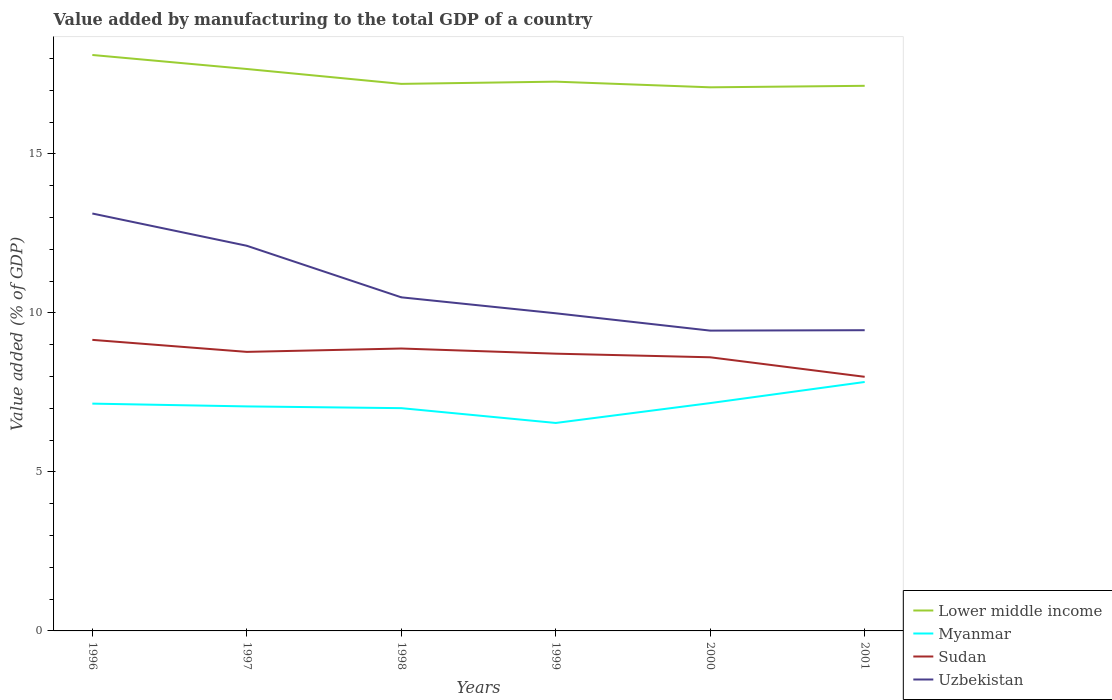How many different coloured lines are there?
Provide a short and direct response. 4. Does the line corresponding to Lower middle income intersect with the line corresponding to Myanmar?
Your answer should be compact. No. Is the number of lines equal to the number of legend labels?
Ensure brevity in your answer.  Yes. Across all years, what is the maximum value added by manufacturing to the total GDP in Lower middle income?
Offer a very short reply. 17.1. What is the total value added by manufacturing to the total GDP in Lower middle income in the graph?
Your response must be concise. 0.47. What is the difference between the highest and the second highest value added by manufacturing to the total GDP in Lower middle income?
Offer a terse response. 1.02. How many years are there in the graph?
Make the answer very short. 6. Does the graph contain grids?
Offer a very short reply. No. Where does the legend appear in the graph?
Make the answer very short. Bottom right. How are the legend labels stacked?
Give a very brief answer. Vertical. What is the title of the graph?
Offer a terse response. Value added by manufacturing to the total GDP of a country. What is the label or title of the Y-axis?
Make the answer very short. Value added (% of GDP). What is the Value added (% of GDP) in Lower middle income in 1996?
Your response must be concise. 18.11. What is the Value added (% of GDP) in Myanmar in 1996?
Ensure brevity in your answer.  7.15. What is the Value added (% of GDP) of Sudan in 1996?
Offer a terse response. 9.15. What is the Value added (% of GDP) of Uzbekistan in 1996?
Offer a very short reply. 13.13. What is the Value added (% of GDP) of Lower middle income in 1997?
Make the answer very short. 17.67. What is the Value added (% of GDP) in Myanmar in 1997?
Your answer should be compact. 7.06. What is the Value added (% of GDP) in Sudan in 1997?
Your answer should be very brief. 8.78. What is the Value added (% of GDP) in Uzbekistan in 1997?
Your response must be concise. 12.11. What is the Value added (% of GDP) of Lower middle income in 1998?
Keep it short and to the point. 17.2. What is the Value added (% of GDP) of Myanmar in 1998?
Your answer should be very brief. 7.01. What is the Value added (% of GDP) of Sudan in 1998?
Provide a short and direct response. 8.88. What is the Value added (% of GDP) in Uzbekistan in 1998?
Keep it short and to the point. 10.49. What is the Value added (% of GDP) in Lower middle income in 1999?
Your answer should be compact. 17.27. What is the Value added (% of GDP) of Myanmar in 1999?
Keep it short and to the point. 6.54. What is the Value added (% of GDP) of Sudan in 1999?
Keep it short and to the point. 8.72. What is the Value added (% of GDP) in Uzbekistan in 1999?
Ensure brevity in your answer.  9.99. What is the Value added (% of GDP) in Lower middle income in 2000?
Make the answer very short. 17.1. What is the Value added (% of GDP) in Myanmar in 2000?
Ensure brevity in your answer.  7.16. What is the Value added (% of GDP) of Sudan in 2000?
Provide a succinct answer. 8.61. What is the Value added (% of GDP) of Uzbekistan in 2000?
Offer a terse response. 9.44. What is the Value added (% of GDP) of Lower middle income in 2001?
Your response must be concise. 17.14. What is the Value added (% of GDP) of Myanmar in 2001?
Offer a terse response. 7.83. What is the Value added (% of GDP) of Sudan in 2001?
Keep it short and to the point. 7.99. What is the Value added (% of GDP) in Uzbekistan in 2001?
Offer a very short reply. 9.46. Across all years, what is the maximum Value added (% of GDP) in Lower middle income?
Keep it short and to the point. 18.11. Across all years, what is the maximum Value added (% of GDP) of Myanmar?
Make the answer very short. 7.83. Across all years, what is the maximum Value added (% of GDP) of Sudan?
Offer a terse response. 9.15. Across all years, what is the maximum Value added (% of GDP) of Uzbekistan?
Offer a terse response. 13.13. Across all years, what is the minimum Value added (% of GDP) of Lower middle income?
Make the answer very short. 17.1. Across all years, what is the minimum Value added (% of GDP) in Myanmar?
Give a very brief answer. 6.54. Across all years, what is the minimum Value added (% of GDP) in Sudan?
Your response must be concise. 7.99. Across all years, what is the minimum Value added (% of GDP) in Uzbekistan?
Your answer should be very brief. 9.44. What is the total Value added (% of GDP) in Lower middle income in the graph?
Your answer should be compact. 104.5. What is the total Value added (% of GDP) in Myanmar in the graph?
Your answer should be compact. 42.75. What is the total Value added (% of GDP) of Sudan in the graph?
Provide a short and direct response. 52.12. What is the total Value added (% of GDP) of Uzbekistan in the graph?
Offer a terse response. 64.62. What is the difference between the Value added (% of GDP) of Lower middle income in 1996 and that in 1997?
Your answer should be very brief. 0.44. What is the difference between the Value added (% of GDP) in Myanmar in 1996 and that in 1997?
Give a very brief answer. 0.09. What is the difference between the Value added (% of GDP) in Sudan in 1996 and that in 1997?
Keep it short and to the point. 0.38. What is the difference between the Value added (% of GDP) in Uzbekistan in 1996 and that in 1997?
Provide a short and direct response. 1.01. What is the difference between the Value added (% of GDP) of Lower middle income in 1996 and that in 1998?
Offer a terse response. 0.91. What is the difference between the Value added (% of GDP) in Myanmar in 1996 and that in 1998?
Give a very brief answer. 0.14. What is the difference between the Value added (% of GDP) of Sudan in 1996 and that in 1998?
Give a very brief answer. 0.27. What is the difference between the Value added (% of GDP) of Uzbekistan in 1996 and that in 1998?
Your answer should be very brief. 2.64. What is the difference between the Value added (% of GDP) in Lower middle income in 1996 and that in 1999?
Offer a very short reply. 0.84. What is the difference between the Value added (% of GDP) of Myanmar in 1996 and that in 1999?
Keep it short and to the point. 0.61. What is the difference between the Value added (% of GDP) in Sudan in 1996 and that in 1999?
Keep it short and to the point. 0.43. What is the difference between the Value added (% of GDP) in Uzbekistan in 1996 and that in 1999?
Make the answer very short. 3.14. What is the difference between the Value added (% of GDP) in Lower middle income in 1996 and that in 2000?
Give a very brief answer. 1.02. What is the difference between the Value added (% of GDP) of Myanmar in 1996 and that in 2000?
Give a very brief answer. -0.02. What is the difference between the Value added (% of GDP) in Sudan in 1996 and that in 2000?
Your answer should be very brief. 0.55. What is the difference between the Value added (% of GDP) in Uzbekistan in 1996 and that in 2000?
Provide a succinct answer. 3.68. What is the difference between the Value added (% of GDP) of Lower middle income in 1996 and that in 2001?
Your answer should be very brief. 0.97. What is the difference between the Value added (% of GDP) of Myanmar in 1996 and that in 2001?
Your answer should be compact. -0.68. What is the difference between the Value added (% of GDP) in Sudan in 1996 and that in 2001?
Offer a terse response. 1.16. What is the difference between the Value added (% of GDP) in Uzbekistan in 1996 and that in 2001?
Offer a terse response. 3.67. What is the difference between the Value added (% of GDP) in Lower middle income in 1997 and that in 1998?
Your response must be concise. 0.47. What is the difference between the Value added (% of GDP) in Myanmar in 1997 and that in 1998?
Offer a terse response. 0.05. What is the difference between the Value added (% of GDP) in Sudan in 1997 and that in 1998?
Ensure brevity in your answer.  -0.11. What is the difference between the Value added (% of GDP) of Uzbekistan in 1997 and that in 1998?
Make the answer very short. 1.62. What is the difference between the Value added (% of GDP) of Lower middle income in 1997 and that in 1999?
Offer a terse response. 0.4. What is the difference between the Value added (% of GDP) of Myanmar in 1997 and that in 1999?
Offer a terse response. 0.52. What is the difference between the Value added (% of GDP) of Sudan in 1997 and that in 1999?
Your answer should be very brief. 0.06. What is the difference between the Value added (% of GDP) of Uzbekistan in 1997 and that in 1999?
Give a very brief answer. 2.12. What is the difference between the Value added (% of GDP) in Lower middle income in 1997 and that in 2000?
Offer a terse response. 0.58. What is the difference between the Value added (% of GDP) in Myanmar in 1997 and that in 2000?
Your answer should be compact. -0.1. What is the difference between the Value added (% of GDP) in Sudan in 1997 and that in 2000?
Keep it short and to the point. 0.17. What is the difference between the Value added (% of GDP) in Uzbekistan in 1997 and that in 2000?
Give a very brief answer. 2.67. What is the difference between the Value added (% of GDP) in Lower middle income in 1997 and that in 2001?
Ensure brevity in your answer.  0.53. What is the difference between the Value added (% of GDP) of Myanmar in 1997 and that in 2001?
Your answer should be very brief. -0.77. What is the difference between the Value added (% of GDP) of Sudan in 1997 and that in 2001?
Your answer should be very brief. 0.78. What is the difference between the Value added (% of GDP) of Uzbekistan in 1997 and that in 2001?
Your response must be concise. 2.66. What is the difference between the Value added (% of GDP) in Lower middle income in 1998 and that in 1999?
Give a very brief answer. -0.07. What is the difference between the Value added (% of GDP) in Myanmar in 1998 and that in 1999?
Offer a very short reply. 0.47. What is the difference between the Value added (% of GDP) in Sudan in 1998 and that in 1999?
Provide a succinct answer. 0.16. What is the difference between the Value added (% of GDP) in Uzbekistan in 1998 and that in 1999?
Give a very brief answer. 0.5. What is the difference between the Value added (% of GDP) in Lower middle income in 1998 and that in 2000?
Offer a terse response. 0.11. What is the difference between the Value added (% of GDP) of Myanmar in 1998 and that in 2000?
Provide a succinct answer. -0.16. What is the difference between the Value added (% of GDP) of Sudan in 1998 and that in 2000?
Your response must be concise. 0.28. What is the difference between the Value added (% of GDP) of Uzbekistan in 1998 and that in 2000?
Your answer should be very brief. 1.05. What is the difference between the Value added (% of GDP) in Lower middle income in 1998 and that in 2001?
Keep it short and to the point. 0.06. What is the difference between the Value added (% of GDP) in Myanmar in 1998 and that in 2001?
Give a very brief answer. -0.82. What is the difference between the Value added (% of GDP) of Sudan in 1998 and that in 2001?
Provide a succinct answer. 0.89. What is the difference between the Value added (% of GDP) of Uzbekistan in 1998 and that in 2001?
Ensure brevity in your answer.  1.03. What is the difference between the Value added (% of GDP) of Lower middle income in 1999 and that in 2000?
Your response must be concise. 0.18. What is the difference between the Value added (% of GDP) of Myanmar in 1999 and that in 2000?
Your answer should be very brief. -0.62. What is the difference between the Value added (% of GDP) of Sudan in 1999 and that in 2000?
Offer a terse response. 0.11. What is the difference between the Value added (% of GDP) in Uzbekistan in 1999 and that in 2000?
Your answer should be very brief. 0.55. What is the difference between the Value added (% of GDP) of Lower middle income in 1999 and that in 2001?
Provide a short and direct response. 0.13. What is the difference between the Value added (% of GDP) of Myanmar in 1999 and that in 2001?
Your answer should be compact. -1.29. What is the difference between the Value added (% of GDP) of Sudan in 1999 and that in 2001?
Your response must be concise. 0.73. What is the difference between the Value added (% of GDP) in Uzbekistan in 1999 and that in 2001?
Your response must be concise. 0.53. What is the difference between the Value added (% of GDP) in Lower middle income in 2000 and that in 2001?
Give a very brief answer. -0.05. What is the difference between the Value added (% of GDP) in Myanmar in 2000 and that in 2001?
Make the answer very short. -0.66. What is the difference between the Value added (% of GDP) in Sudan in 2000 and that in 2001?
Offer a terse response. 0.61. What is the difference between the Value added (% of GDP) of Uzbekistan in 2000 and that in 2001?
Give a very brief answer. -0.01. What is the difference between the Value added (% of GDP) of Lower middle income in 1996 and the Value added (% of GDP) of Myanmar in 1997?
Make the answer very short. 11.05. What is the difference between the Value added (% of GDP) of Lower middle income in 1996 and the Value added (% of GDP) of Sudan in 1997?
Keep it short and to the point. 9.34. What is the difference between the Value added (% of GDP) in Lower middle income in 1996 and the Value added (% of GDP) in Uzbekistan in 1997?
Provide a succinct answer. 6. What is the difference between the Value added (% of GDP) of Myanmar in 1996 and the Value added (% of GDP) of Sudan in 1997?
Your answer should be very brief. -1.63. What is the difference between the Value added (% of GDP) in Myanmar in 1996 and the Value added (% of GDP) in Uzbekistan in 1997?
Your response must be concise. -4.96. What is the difference between the Value added (% of GDP) in Sudan in 1996 and the Value added (% of GDP) in Uzbekistan in 1997?
Keep it short and to the point. -2.96. What is the difference between the Value added (% of GDP) in Lower middle income in 1996 and the Value added (% of GDP) in Myanmar in 1998?
Offer a terse response. 11.11. What is the difference between the Value added (% of GDP) in Lower middle income in 1996 and the Value added (% of GDP) in Sudan in 1998?
Provide a short and direct response. 9.23. What is the difference between the Value added (% of GDP) in Lower middle income in 1996 and the Value added (% of GDP) in Uzbekistan in 1998?
Your answer should be compact. 7.62. What is the difference between the Value added (% of GDP) in Myanmar in 1996 and the Value added (% of GDP) in Sudan in 1998?
Your answer should be compact. -1.73. What is the difference between the Value added (% of GDP) of Myanmar in 1996 and the Value added (% of GDP) of Uzbekistan in 1998?
Keep it short and to the point. -3.34. What is the difference between the Value added (% of GDP) of Sudan in 1996 and the Value added (% of GDP) of Uzbekistan in 1998?
Ensure brevity in your answer.  -1.34. What is the difference between the Value added (% of GDP) in Lower middle income in 1996 and the Value added (% of GDP) in Myanmar in 1999?
Offer a terse response. 11.57. What is the difference between the Value added (% of GDP) of Lower middle income in 1996 and the Value added (% of GDP) of Sudan in 1999?
Provide a short and direct response. 9.39. What is the difference between the Value added (% of GDP) in Lower middle income in 1996 and the Value added (% of GDP) in Uzbekistan in 1999?
Give a very brief answer. 8.12. What is the difference between the Value added (% of GDP) of Myanmar in 1996 and the Value added (% of GDP) of Sudan in 1999?
Keep it short and to the point. -1.57. What is the difference between the Value added (% of GDP) in Myanmar in 1996 and the Value added (% of GDP) in Uzbekistan in 1999?
Give a very brief answer. -2.84. What is the difference between the Value added (% of GDP) of Sudan in 1996 and the Value added (% of GDP) of Uzbekistan in 1999?
Provide a short and direct response. -0.84. What is the difference between the Value added (% of GDP) of Lower middle income in 1996 and the Value added (% of GDP) of Myanmar in 2000?
Ensure brevity in your answer.  10.95. What is the difference between the Value added (% of GDP) in Lower middle income in 1996 and the Value added (% of GDP) in Sudan in 2000?
Offer a terse response. 9.51. What is the difference between the Value added (% of GDP) of Lower middle income in 1996 and the Value added (% of GDP) of Uzbekistan in 2000?
Offer a terse response. 8.67. What is the difference between the Value added (% of GDP) of Myanmar in 1996 and the Value added (% of GDP) of Sudan in 2000?
Keep it short and to the point. -1.46. What is the difference between the Value added (% of GDP) in Myanmar in 1996 and the Value added (% of GDP) in Uzbekistan in 2000?
Keep it short and to the point. -2.3. What is the difference between the Value added (% of GDP) in Sudan in 1996 and the Value added (% of GDP) in Uzbekistan in 2000?
Make the answer very short. -0.29. What is the difference between the Value added (% of GDP) in Lower middle income in 1996 and the Value added (% of GDP) in Myanmar in 2001?
Your response must be concise. 10.28. What is the difference between the Value added (% of GDP) of Lower middle income in 1996 and the Value added (% of GDP) of Sudan in 2001?
Keep it short and to the point. 10.12. What is the difference between the Value added (% of GDP) in Lower middle income in 1996 and the Value added (% of GDP) in Uzbekistan in 2001?
Offer a terse response. 8.66. What is the difference between the Value added (% of GDP) in Myanmar in 1996 and the Value added (% of GDP) in Sudan in 2001?
Your answer should be compact. -0.84. What is the difference between the Value added (% of GDP) of Myanmar in 1996 and the Value added (% of GDP) of Uzbekistan in 2001?
Your response must be concise. -2.31. What is the difference between the Value added (% of GDP) of Sudan in 1996 and the Value added (% of GDP) of Uzbekistan in 2001?
Your answer should be very brief. -0.3. What is the difference between the Value added (% of GDP) of Lower middle income in 1997 and the Value added (% of GDP) of Myanmar in 1998?
Keep it short and to the point. 10.67. What is the difference between the Value added (% of GDP) of Lower middle income in 1997 and the Value added (% of GDP) of Sudan in 1998?
Make the answer very short. 8.79. What is the difference between the Value added (% of GDP) in Lower middle income in 1997 and the Value added (% of GDP) in Uzbekistan in 1998?
Ensure brevity in your answer.  7.18. What is the difference between the Value added (% of GDP) in Myanmar in 1997 and the Value added (% of GDP) in Sudan in 1998?
Offer a very short reply. -1.82. What is the difference between the Value added (% of GDP) in Myanmar in 1997 and the Value added (% of GDP) in Uzbekistan in 1998?
Offer a very short reply. -3.43. What is the difference between the Value added (% of GDP) of Sudan in 1997 and the Value added (% of GDP) of Uzbekistan in 1998?
Give a very brief answer. -1.72. What is the difference between the Value added (% of GDP) in Lower middle income in 1997 and the Value added (% of GDP) in Myanmar in 1999?
Ensure brevity in your answer.  11.13. What is the difference between the Value added (% of GDP) in Lower middle income in 1997 and the Value added (% of GDP) in Sudan in 1999?
Ensure brevity in your answer.  8.95. What is the difference between the Value added (% of GDP) in Lower middle income in 1997 and the Value added (% of GDP) in Uzbekistan in 1999?
Keep it short and to the point. 7.68. What is the difference between the Value added (% of GDP) of Myanmar in 1997 and the Value added (% of GDP) of Sudan in 1999?
Provide a short and direct response. -1.66. What is the difference between the Value added (% of GDP) in Myanmar in 1997 and the Value added (% of GDP) in Uzbekistan in 1999?
Make the answer very short. -2.93. What is the difference between the Value added (% of GDP) of Sudan in 1997 and the Value added (% of GDP) of Uzbekistan in 1999?
Provide a short and direct response. -1.21. What is the difference between the Value added (% of GDP) in Lower middle income in 1997 and the Value added (% of GDP) in Myanmar in 2000?
Provide a succinct answer. 10.51. What is the difference between the Value added (% of GDP) of Lower middle income in 1997 and the Value added (% of GDP) of Sudan in 2000?
Provide a succinct answer. 9.07. What is the difference between the Value added (% of GDP) of Lower middle income in 1997 and the Value added (% of GDP) of Uzbekistan in 2000?
Ensure brevity in your answer.  8.23. What is the difference between the Value added (% of GDP) of Myanmar in 1997 and the Value added (% of GDP) of Sudan in 2000?
Your answer should be very brief. -1.54. What is the difference between the Value added (% of GDP) of Myanmar in 1997 and the Value added (% of GDP) of Uzbekistan in 2000?
Provide a short and direct response. -2.38. What is the difference between the Value added (% of GDP) of Sudan in 1997 and the Value added (% of GDP) of Uzbekistan in 2000?
Give a very brief answer. -0.67. What is the difference between the Value added (% of GDP) in Lower middle income in 1997 and the Value added (% of GDP) in Myanmar in 2001?
Offer a terse response. 9.84. What is the difference between the Value added (% of GDP) in Lower middle income in 1997 and the Value added (% of GDP) in Sudan in 2001?
Offer a very short reply. 9.68. What is the difference between the Value added (% of GDP) of Lower middle income in 1997 and the Value added (% of GDP) of Uzbekistan in 2001?
Make the answer very short. 8.21. What is the difference between the Value added (% of GDP) of Myanmar in 1997 and the Value added (% of GDP) of Sudan in 2001?
Your answer should be very brief. -0.93. What is the difference between the Value added (% of GDP) of Myanmar in 1997 and the Value added (% of GDP) of Uzbekistan in 2001?
Your answer should be very brief. -2.4. What is the difference between the Value added (% of GDP) of Sudan in 1997 and the Value added (% of GDP) of Uzbekistan in 2001?
Your answer should be compact. -0.68. What is the difference between the Value added (% of GDP) in Lower middle income in 1998 and the Value added (% of GDP) in Myanmar in 1999?
Offer a very short reply. 10.66. What is the difference between the Value added (% of GDP) of Lower middle income in 1998 and the Value added (% of GDP) of Sudan in 1999?
Your response must be concise. 8.48. What is the difference between the Value added (% of GDP) in Lower middle income in 1998 and the Value added (% of GDP) in Uzbekistan in 1999?
Your answer should be very brief. 7.21. What is the difference between the Value added (% of GDP) of Myanmar in 1998 and the Value added (% of GDP) of Sudan in 1999?
Keep it short and to the point. -1.71. What is the difference between the Value added (% of GDP) in Myanmar in 1998 and the Value added (% of GDP) in Uzbekistan in 1999?
Make the answer very short. -2.98. What is the difference between the Value added (% of GDP) in Sudan in 1998 and the Value added (% of GDP) in Uzbekistan in 1999?
Your response must be concise. -1.11. What is the difference between the Value added (% of GDP) in Lower middle income in 1998 and the Value added (% of GDP) in Myanmar in 2000?
Provide a succinct answer. 10.04. What is the difference between the Value added (% of GDP) in Lower middle income in 1998 and the Value added (% of GDP) in Sudan in 2000?
Give a very brief answer. 8.6. What is the difference between the Value added (% of GDP) in Lower middle income in 1998 and the Value added (% of GDP) in Uzbekistan in 2000?
Offer a very short reply. 7.76. What is the difference between the Value added (% of GDP) in Myanmar in 1998 and the Value added (% of GDP) in Sudan in 2000?
Your response must be concise. -1.6. What is the difference between the Value added (% of GDP) of Myanmar in 1998 and the Value added (% of GDP) of Uzbekistan in 2000?
Make the answer very short. -2.44. What is the difference between the Value added (% of GDP) in Sudan in 1998 and the Value added (% of GDP) in Uzbekistan in 2000?
Provide a short and direct response. -0.56. What is the difference between the Value added (% of GDP) of Lower middle income in 1998 and the Value added (% of GDP) of Myanmar in 2001?
Your answer should be very brief. 9.37. What is the difference between the Value added (% of GDP) in Lower middle income in 1998 and the Value added (% of GDP) in Sudan in 2001?
Make the answer very short. 9.21. What is the difference between the Value added (% of GDP) in Lower middle income in 1998 and the Value added (% of GDP) in Uzbekistan in 2001?
Provide a succinct answer. 7.75. What is the difference between the Value added (% of GDP) of Myanmar in 1998 and the Value added (% of GDP) of Sudan in 2001?
Make the answer very short. -0.99. What is the difference between the Value added (% of GDP) in Myanmar in 1998 and the Value added (% of GDP) in Uzbekistan in 2001?
Offer a very short reply. -2.45. What is the difference between the Value added (% of GDP) of Sudan in 1998 and the Value added (% of GDP) of Uzbekistan in 2001?
Make the answer very short. -0.58. What is the difference between the Value added (% of GDP) of Lower middle income in 1999 and the Value added (% of GDP) of Myanmar in 2000?
Give a very brief answer. 10.11. What is the difference between the Value added (% of GDP) in Lower middle income in 1999 and the Value added (% of GDP) in Sudan in 2000?
Your response must be concise. 8.67. What is the difference between the Value added (% of GDP) in Lower middle income in 1999 and the Value added (% of GDP) in Uzbekistan in 2000?
Offer a terse response. 7.83. What is the difference between the Value added (% of GDP) of Myanmar in 1999 and the Value added (% of GDP) of Sudan in 2000?
Your answer should be very brief. -2.07. What is the difference between the Value added (% of GDP) of Myanmar in 1999 and the Value added (% of GDP) of Uzbekistan in 2000?
Provide a short and direct response. -2.9. What is the difference between the Value added (% of GDP) in Sudan in 1999 and the Value added (% of GDP) in Uzbekistan in 2000?
Provide a succinct answer. -0.72. What is the difference between the Value added (% of GDP) of Lower middle income in 1999 and the Value added (% of GDP) of Myanmar in 2001?
Make the answer very short. 9.44. What is the difference between the Value added (% of GDP) of Lower middle income in 1999 and the Value added (% of GDP) of Sudan in 2001?
Offer a terse response. 9.28. What is the difference between the Value added (% of GDP) in Lower middle income in 1999 and the Value added (% of GDP) in Uzbekistan in 2001?
Provide a short and direct response. 7.82. What is the difference between the Value added (% of GDP) in Myanmar in 1999 and the Value added (% of GDP) in Sudan in 2001?
Offer a terse response. -1.45. What is the difference between the Value added (% of GDP) in Myanmar in 1999 and the Value added (% of GDP) in Uzbekistan in 2001?
Make the answer very short. -2.92. What is the difference between the Value added (% of GDP) in Sudan in 1999 and the Value added (% of GDP) in Uzbekistan in 2001?
Ensure brevity in your answer.  -0.74. What is the difference between the Value added (% of GDP) of Lower middle income in 2000 and the Value added (% of GDP) of Myanmar in 2001?
Your answer should be compact. 9.27. What is the difference between the Value added (% of GDP) of Lower middle income in 2000 and the Value added (% of GDP) of Sudan in 2001?
Give a very brief answer. 9.1. What is the difference between the Value added (% of GDP) of Lower middle income in 2000 and the Value added (% of GDP) of Uzbekistan in 2001?
Offer a very short reply. 7.64. What is the difference between the Value added (% of GDP) of Myanmar in 2000 and the Value added (% of GDP) of Sudan in 2001?
Offer a very short reply. -0.83. What is the difference between the Value added (% of GDP) of Myanmar in 2000 and the Value added (% of GDP) of Uzbekistan in 2001?
Offer a terse response. -2.29. What is the difference between the Value added (% of GDP) in Sudan in 2000 and the Value added (% of GDP) in Uzbekistan in 2001?
Your response must be concise. -0.85. What is the average Value added (% of GDP) of Lower middle income per year?
Offer a terse response. 17.42. What is the average Value added (% of GDP) in Myanmar per year?
Give a very brief answer. 7.12. What is the average Value added (% of GDP) of Sudan per year?
Your answer should be compact. 8.69. What is the average Value added (% of GDP) in Uzbekistan per year?
Ensure brevity in your answer.  10.77. In the year 1996, what is the difference between the Value added (% of GDP) of Lower middle income and Value added (% of GDP) of Myanmar?
Provide a short and direct response. 10.96. In the year 1996, what is the difference between the Value added (% of GDP) of Lower middle income and Value added (% of GDP) of Sudan?
Ensure brevity in your answer.  8.96. In the year 1996, what is the difference between the Value added (% of GDP) in Lower middle income and Value added (% of GDP) in Uzbekistan?
Your response must be concise. 4.99. In the year 1996, what is the difference between the Value added (% of GDP) in Myanmar and Value added (% of GDP) in Sudan?
Give a very brief answer. -2.01. In the year 1996, what is the difference between the Value added (% of GDP) of Myanmar and Value added (% of GDP) of Uzbekistan?
Provide a succinct answer. -5.98. In the year 1996, what is the difference between the Value added (% of GDP) in Sudan and Value added (% of GDP) in Uzbekistan?
Provide a succinct answer. -3.97. In the year 1997, what is the difference between the Value added (% of GDP) in Lower middle income and Value added (% of GDP) in Myanmar?
Provide a succinct answer. 10.61. In the year 1997, what is the difference between the Value added (% of GDP) in Lower middle income and Value added (% of GDP) in Sudan?
Your answer should be compact. 8.9. In the year 1997, what is the difference between the Value added (% of GDP) in Lower middle income and Value added (% of GDP) in Uzbekistan?
Your response must be concise. 5.56. In the year 1997, what is the difference between the Value added (% of GDP) of Myanmar and Value added (% of GDP) of Sudan?
Make the answer very short. -1.72. In the year 1997, what is the difference between the Value added (% of GDP) in Myanmar and Value added (% of GDP) in Uzbekistan?
Keep it short and to the point. -5.05. In the year 1997, what is the difference between the Value added (% of GDP) in Sudan and Value added (% of GDP) in Uzbekistan?
Offer a terse response. -3.34. In the year 1998, what is the difference between the Value added (% of GDP) in Lower middle income and Value added (% of GDP) in Myanmar?
Provide a succinct answer. 10.2. In the year 1998, what is the difference between the Value added (% of GDP) of Lower middle income and Value added (% of GDP) of Sudan?
Provide a short and direct response. 8.32. In the year 1998, what is the difference between the Value added (% of GDP) in Lower middle income and Value added (% of GDP) in Uzbekistan?
Provide a short and direct response. 6.71. In the year 1998, what is the difference between the Value added (% of GDP) of Myanmar and Value added (% of GDP) of Sudan?
Offer a very short reply. -1.88. In the year 1998, what is the difference between the Value added (% of GDP) of Myanmar and Value added (% of GDP) of Uzbekistan?
Offer a terse response. -3.49. In the year 1998, what is the difference between the Value added (% of GDP) in Sudan and Value added (% of GDP) in Uzbekistan?
Your answer should be very brief. -1.61. In the year 1999, what is the difference between the Value added (% of GDP) of Lower middle income and Value added (% of GDP) of Myanmar?
Your answer should be compact. 10.73. In the year 1999, what is the difference between the Value added (% of GDP) in Lower middle income and Value added (% of GDP) in Sudan?
Give a very brief answer. 8.55. In the year 1999, what is the difference between the Value added (% of GDP) in Lower middle income and Value added (% of GDP) in Uzbekistan?
Offer a very short reply. 7.28. In the year 1999, what is the difference between the Value added (% of GDP) of Myanmar and Value added (% of GDP) of Sudan?
Your answer should be compact. -2.18. In the year 1999, what is the difference between the Value added (% of GDP) of Myanmar and Value added (% of GDP) of Uzbekistan?
Offer a very short reply. -3.45. In the year 1999, what is the difference between the Value added (% of GDP) in Sudan and Value added (% of GDP) in Uzbekistan?
Your answer should be very brief. -1.27. In the year 2000, what is the difference between the Value added (% of GDP) in Lower middle income and Value added (% of GDP) in Myanmar?
Provide a short and direct response. 9.93. In the year 2000, what is the difference between the Value added (% of GDP) of Lower middle income and Value added (% of GDP) of Sudan?
Make the answer very short. 8.49. In the year 2000, what is the difference between the Value added (% of GDP) in Lower middle income and Value added (% of GDP) in Uzbekistan?
Offer a terse response. 7.65. In the year 2000, what is the difference between the Value added (% of GDP) in Myanmar and Value added (% of GDP) in Sudan?
Your answer should be compact. -1.44. In the year 2000, what is the difference between the Value added (% of GDP) of Myanmar and Value added (% of GDP) of Uzbekistan?
Provide a short and direct response. -2.28. In the year 2000, what is the difference between the Value added (% of GDP) in Sudan and Value added (% of GDP) in Uzbekistan?
Keep it short and to the point. -0.84. In the year 2001, what is the difference between the Value added (% of GDP) of Lower middle income and Value added (% of GDP) of Myanmar?
Offer a very short reply. 9.31. In the year 2001, what is the difference between the Value added (% of GDP) in Lower middle income and Value added (% of GDP) in Sudan?
Make the answer very short. 9.15. In the year 2001, what is the difference between the Value added (% of GDP) of Lower middle income and Value added (% of GDP) of Uzbekistan?
Offer a very short reply. 7.69. In the year 2001, what is the difference between the Value added (% of GDP) of Myanmar and Value added (% of GDP) of Sudan?
Keep it short and to the point. -0.16. In the year 2001, what is the difference between the Value added (% of GDP) in Myanmar and Value added (% of GDP) in Uzbekistan?
Provide a succinct answer. -1.63. In the year 2001, what is the difference between the Value added (% of GDP) in Sudan and Value added (% of GDP) in Uzbekistan?
Ensure brevity in your answer.  -1.47. What is the ratio of the Value added (% of GDP) of Lower middle income in 1996 to that in 1997?
Ensure brevity in your answer.  1.02. What is the ratio of the Value added (% of GDP) of Myanmar in 1996 to that in 1997?
Provide a succinct answer. 1.01. What is the ratio of the Value added (% of GDP) of Sudan in 1996 to that in 1997?
Make the answer very short. 1.04. What is the ratio of the Value added (% of GDP) in Uzbekistan in 1996 to that in 1997?
Ensure brevity in your answer.  1.08. What is the ratio of the Value added (% of GDP) of Lower middle income in 1996 to that in 1998?
Ensure brevity in your answer.  1.05. What is the ratio of the Value added (% of GDP) in Myanmar in 1996 to that in 1998?
Ensure brevity in your answer.  1.02. What is the ratio of the Value added (% of GDP) of Sudan in 1996 to that in 1998?
Provide a short and direct response. 1.03. What is the ratio of the Value added (% of GDP) of Uzbekistan in 1996 to that in 1998?
Offer a terse response. 1.25. What is the ratio of the Value added (% of GDP) of Lower middle income in 1996 to that in 1999?
Your response must be concise. 1.05. What is the ratio of the Value added (% of GDP) in Myanmar in 1996 to that in 1999?
Your answer should be compact. 1.09. What is the ratio of the Value added (% of GDP) in Sudan in 1996 to that in 1999?
Keep it short and to the point. 1.05. What is the ratio of the Value added (% of GDP) in Uzbekistan in 1996 to that in 1999?
Ensure brevity in your answer.  1.31. What is the ratio of the Value added (% of GDP) of Lower middle income in 1996 to that in 2000?
Make the answer very short. 1.06. What is the ratio of the Value added (% of GDP) of Myanmar in 1996 to that in 2000?
Offer a very short reply. 1. What is the ratio of the Value added (% of GDP) of Sudan in 1996 to that in 2000?
Make the answer very short. 1.06. What is the ratio of the Value added (% of GDP) in Uzbekistan in 1996 to that in 2000?
Ensure brevity in your answer.  1.39. What is the ratio of the Value added (% of GDP) in Lower middle income in 1996 to that in 2001?
Offer a terse response. 1.06. What is the ratio of the Value added (% of GDP) of Myanmar in 1996 to that in 2001?
Your answer should be compact. 0.91. What is the ratio of the Value added (% of GDP) in Sudan in 1996 to that in 2001?
Your answer should be compact. 1.15. What is the ratio of the Value added (% of GDP) of Uzbekistan in 1996 to that in 2001?
Your answer should be very brief. 1.39. What is the ratio of the Value added (% of GDP) in Lower middle income in 1997 to that in 1998?
Your answer should be very brief. 1.03. What is the ratio of the Value added (% of GDP) of Sudan in 1997 to that in 1998?
Offer a terse response. 0.99. What is the ratio of the Value added (% of GDP) of Uzbekistan in 1997 to that in 1998?
Make the answer very short. 1.15. What is the ratio of the Value added (% of GDP) in Lower middle income in 1997 to that in 1999?
Offer a very short reply. 1.02. What is the ratio of the Value added (% of GDP) in Myanmar in 1997 to that in 1999?
Keep it short and to the point. 1.08. What is the ratio of the Value added (% of GDP) in Uzbekistan in 1997 to that in 1999?
Give a very brief answer. 1.21. What is the ratio of the Value added (% of GDP) in Lower middle income in 1997 to that in 2000?
Your answer should be very brief. 1.03. What is the ratio of the Value added (% of GDP) of Myanmar in 1997 to that in 2000?
Make the answer very short. 0.99. What is the ratio of the Value added (% of GDP) in Sudan in 1997 to that in 2000?
Offer a terse response. 1.02. What is the ratio of the Value added (% of GDP) in Uzbekistan in 1997 to that in 2000?
Offer a terse response. 1.28. What is the ratio of the Value added (% of GDP) in Lower middle income in 1997 to that in 2001?
Provide a succinct answer. 1.03. What is the ratio of the Value added (% of GDP) in Myanmar in 1997 to that in 2001?
Provide a short and direct response. 0.9. What is the ratio of the Value added (% of GDP) in Sudan in 1997 to that in 2001?
Ensure brevity in your answer.  1.1. What is the ratio of the Value added (% of GDP) in Uzbekistan in 1997 to that in 2001?
Your answer should be compact. 1.28. What is the ratio of the Value added (% of GDP) in Lower middle income in 1998 to that in 1999?
Ensure brevity in your answer.  1. What is the ratio of the Value added (% of GDP) in Myanmar in 1998 to that in 1999?
Make the answer very short. 1.07. What is the ratio of the Value added (% of GDP) of Sudan in 1998 to that in 1999?
Offer a terse response. 1.02. What is the ratio of the Value added (% of GDP) of Uzbekistan in 1998 to that in 1999?
Offer a terse response. 1.05. What is the ratio of the Value added (% of GDP) of Myanmar in 1998 to that in 2000?
Ensure brevity in your answer.  0.98. What is the ratio of the Value added (% of GDP) in Sudan in 1998 to that in 2000?
Give a very brief answer. 1.03. What is the ratio of the Value added (% of GDP) in Uzbekistan in 1998 to that in 2000?
Offer a terse response. 1.11. What is the ratio of the Value added (% of GDP) in Myanmar in 1998 to that in 2001?
Your answer should be compact. 0.89. What is the ratio of the Value added (% of GDP) in Sudan in 1998 to that in 2001?
Provide a succinct answer. 1.11. What is the ratio of the Value added (% of GDP) of Uzbekistan in 1998 to that in 2001?
Give a very brief answer. 1.11. What is the ratio of the Value added (% of GDP) in Lower middle income in 1999 to that in 2000?
Your answer should be very brief. 1.01. What is the ratio of the Value added (% of GDP) of Myanmar in 1999 to that in 2000?
Make the answer very short. 0.91. What is the ratio of the Value added (% of GDP) in Sudan in 1999 to that in 2000?
Offer a very short reply. 1.01. What is the ratio of the Value added (% of GDP) in Uzbekistan in 1999 to that in 2000?
Keep it short and to the point. 1.06. What is the ratio of the Value added (% of GDP) in Lower middle income in 1999 to that in 2001?
Your answer should be very brief. 1.01. What is the ratio of the Value added (% of GDP) in Myanmar in 1999 to that in 2001?
Keep it short and to the point. 0.84. What is the ratio of the Value added (% of GDP) in Sudan in 1999 to that in 2001?
Ensure brevity in your answer.  1.09. What is the ratio of the Value added (% of GDP) in Uzbekistan in 1999 to that in 2001?
Provide a succinct answer. 1.06. What is the ratio of the Value added (% of GDP) in Myanmar in 2000 to that in 2001?
Keep it short and to the point. 0.92. What is the ratio of the Value added (% of GDP) in Sudan in 2000 to that in 2001?
Your response must be concise. 1.08. What is the ratio of the Value added (% of GDP) in Uzbekistan in 2000 to that in 2001?
Provide a succinct answer. 1. What is the difference between the highest and the second highest Value added (% of GDP) in Lower middle income?
Offer a terse response. 0.44. What is the difference between the highest and the second highest Value added (% of GDP) in Myanmar?
Offer a very short reply. 0.66. What is the difference between the highest and the second highest Value added (% of GDP) in Sudan?
Keep it short and to the point. 0.27. What is the difference between the highest and the second highest Value added (% of GDP) in Uzbekistan?
Your answer should be compact. 1.01. What is the difference between the highest and the lowest Value added (% of GDP) in Lower middle income?
Offer a very short reply. 1.02. What is the difference between the highest and the lowest Value added (% of GDP) of Myanmar?
Offer a terse response. 1.29. What is the difference between the highest and the lowest Value added (% of GDP) of Sudan?
Offer a terse response. 1.16. What is the difference between the highest and the lowest Value added (% of GDP) of Uzbekistan?
Offer a very short reply. 3.68. 